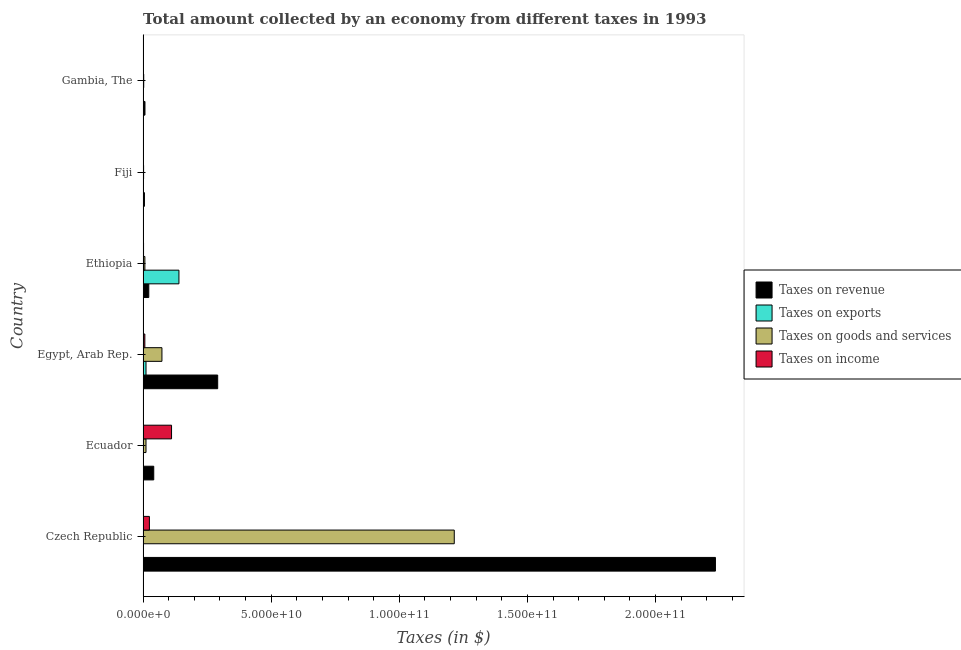How many different coloured bars are there?
Provide a short and direct response. 4. Are the number of bars per tick equal to the number of legend labels?
Make the answer very short. Yes. What is the label of the 2nd group of bars from the top?
Give a very brief answer. Fiji. What is the amount collected as tax on exports in Egypt, Arab Rep.?
Your answer should be compact. 1.15e+09. Across all countries, what is the maximum amount collected as tax on goods?
Ensure brevity in your answer.  1.21e+11. Across all countries, what is the minimum amount collected as tax on goods?
Provide a succinct answer. 2.04e+08. In which country was the amount collected as tax on revenue maximum?
Your response must be concise. Czech Republic. In which country was the amount collected as tax on goods minimum?
Give a very brief answer. Fiji. What is the total amount collected as tax on income in the graph?
Provide a short and direct response. 1.46e+1. What is the difference between the amount collected as tax on goods in Egypt, Arab Rep. and that in Gambia, The?
Your answer should be compact. 7.11e+09. What is the difference between the amount collected as tax on income in Fiji and the amount collected as tax on revenue in Czech Republic?
Make the answer very short. -2.23e+11. What is the average amount collected as tax on exports per country?
Your answer should be very brief. 2.53e+09. What is the difference between the amount collected as tax on income and amount collected as tax on revenue in Egypt, Arab Rep.?
Give a very brief answer. -2.84e+1. What is the ratio of the amount collected as tax on income in Ethiopia to that in Fiji?
Give a very brief answer. 1.67. Is the amount collected as tax on income in Egypt, Arab Rep. less than that in Fiji?
Your response must be concise. No. Is the difference between the amount collected as tax on goods in Czech Republic and Egypt, Arab Rep. greater than the difference between the amount collected as tax on income in Czech Republic and Egypt, Arab Rep.?
Offer a very short reply. Yes. What is the difference between the highest and the second highest amount collected as tax on income?
Give a very brief answer. 8.64e+09. What is the difference between the highest and the lowest amount collected as tax on revenue?
Provide a short and direct response. 2.23e+11. In how many countries, is the amount collected as tax on goods greater than the average amount collected as tax on goods taken over all countries?
Offer a very short reply. 1. Is the sum of the amount collected as tax on income in Czech Republic and Fiji greater than the maximum amount collected as tax on exports across all countries?
Keep it short and to the point. No. What does the 2nd bar from the top in Ecuador represents?
Keep it short and to the point. Taxes on goods and services. What does the 1st bar from the bottom in Ethiopia represents?
Your response must be concise. Taxes on revenue. Is it the case that in every country, the sum of the amount collected as tax on revenue and amount collected as tax on exports is greater than the amount collected as tax on goods?
Provide a succinct answer. Yes. How many countries are there in the graph?
Provide a succinct answer. 6. What is the difference between two consecutive major ticks on the X-axis?
Provide a succinct answer. 5.00e+1. Are the values on the major ticks of X-axis written in scientific E-notation?
Offer a terse response. Yes. Does the graph contain any zero values?
Your answer should be very brief. No. Where does the legend appear in the graph?
Your answer should be compact. Center right. How many legend labels are there?
Your response must be concise. 4. How are the legend labels stacked?
Provide a short and direct response. Vertical. What is the title of the graph?
Provide a short and direct response. Total amount collected by an economy from different taxes in 1993. Does "Primary" appear as one of the legend labels in the graph?
Ensure brevity in your answer.  No. What is the label or title of the X-axis?
Offer a terse response. Taxes (in $). What is the label or title of the Y-axis?
Ensure brevity in your answer.  Country. What is the Taxes (in $) of Taxes on revenue in Czech Republic?
Ensure brevity in your answer.  2.23e+11. What is the Taxes (in $) in Taxes on exports in Czech Republic?
Offer a terse response. 10000. What is the Taxes (in $) of Taxes on goods and services in Czech Republic?
Ensure brevity in your answer.  1.21e+11. What is the Taxes (in $) of Taxes on income in Czech Republic?
Your answer should be very brief. 2.48e+09. What is the Taxes (in $) of Taxes on revenue in Ecuador?
Give a very brief answer. 4.17e+09. What is the Taxes (in $) in Taxes on exports in Ecuador?
Your answer should be compact. 10000. What is the Taxes (in $) of Taxes on goods and services in Ecuador?
Make the answer very short. 1.15e+09. What is the Taxes (in $) of Taxes on income in Ecuador?
Provide a succinct answer. 1.11e+1. What is the Taxes (in $) of Taxes on revenue in Egypt, Arab Rep.?
Keep it short and to the point. 2.91e+1. What is the Taxes (in $) in Taxes on exports in Egypt, Arab Rep.?
Offer a terse response. 1.15e+09. What is the Taxes (in $) of Taxes on goods and services in Egypt, Arab Rep.?
Offer a very short reply. 7.36e+09. What is the Taxes (in $) of Taxes on income in Egypt, Arab Rep.?
Your answer should be compact. 6.94e+08. What is the Taxes (in $) of Taxes on revenue in Ethiopia?
Your answer should be compact. 2.23e+09. What is the Taxes (in $) of Taxes on exports in Ethiopia?
Provide a short and direct response. 1.40e+1. What is the Taxes (in $) of Taxes on goods and services in Ethiopia?
Offer a very short reply. 7.09e+08. What is the Taxes (in $) of Taxes on income in Ethiopia?
Make the answer very short. 1.91e+08. What is the Taxes (in $) in Taxes on revenue in Fiji?
Ensure brevity in your answer.  5.40e+08. What is the Taxes (in $) in Taxes on goods and services in Fiji?
Provide a short and direct response. 2.04e+08. What is the Taxes (in $) in Taxes on income in Fiji?
Provide a short and direct response. 1.15e+08. What is the Taxes (in $) in Taxes on revenue in Gambia, The?
Keep it short and to the point. 7.44e+08. What is the Taxes (in $) in Taxes on exports in Gambia, The?
Offer a terse response. 3.65e+05. What is the Taxes (in $) of Taxes on goods and services in Gambia, The?
Ensure brevity in your answer.  2.57e+08. What is the Taxes (in $) in Taxes on income in Gambia, The?
Offer a very short reply. 1.10e+07. Across all countries, what is the maximum Taxes (in $) of Taxes on revenue?
Provide a succinct answer. 2.23e+11. Across all countries, what is the maximum Taxes (in $) in Taxes on exports?
Keep it short and to the point. 1.40e+1. Across all countries, what is the maximum Taxes (in $) in Taxes on goods and services?
Provide a short and direct response. 1.21e+11. Across all countries, what is the maximum Taxes (in $) of Taxes on income?
Your answer should be very brief. 1.11e+1. Across all countries, what is the minimum Taxes (in $) in Taxes on revenue?
Your answer should be compact. 5.40e+08. Across all countries, what is the minimum Taxes (in $) of Taxes on exports?
Give a very brief answer. 10000. Across all countries, what is the minimum Taxes (in $) in Taxes on goods and services?
Provide a succinct answer. 2.04e+08. Across all countries, what is the minimum Taxes (in $) in Taxes on income?
Your response must be concise. 1.10e+07. What is the total Taxes (in $) of Taxes on revenue in the graph?
Make the answer very short. 2.60e+11. What is the total Taxes (in $) of Taxes on exports in the graph?
Your answer should be compact. 1.52e+1. What is the total Taxes (in $) of Taxes on goods and services in the graph?
Provide a succinct answer. 1.31e+11. What is the total Taxes (in $) of Taxes on income in the graph?
Give a very brief answer. 1.46e+1. What is the difference between the Taxes (in $) in Taxes on revenue in Czech Republic and that in Ecuador?
Ensure brevity in your answer.  2.19e+11. What is the difference between the Taxes (in $) in Taxes on goods and services in Czech Republic and that in Ecuador?
Keep it short and to the point. 1.20e+11. What is the difference between the Taxes (in $) of Taxes on income in Czech Republic and that in Ecuador?
Your response must be concise. -8.64e+09. What is the difference between the Taxes (in $) in Taxes on revenue in Czech Republic and that in Egypt, Arab Rep.?
Ensure brevity in your answer.  1.94e+11. What is the difference between the Taxes (in $) in Taxes on exports in Czech Republic and that in Egypt, Arab Rep.?
Provide a short and direct response. -1.15e+09. What is the difference between the Taxes (in $) in Taxes on goods and services in Czech Republic and that in Egypt, Arab Rep.?
Provide a succinct answer. 1.14e+11. What is the difference between the Taxes (in $) in Taxes on income in Czech Republic and that in Egypt, Arab Rep.?
Your answer should be very brief. 1.78e+09. What is the difference between the Taxes (in $) of Taxes on revenue in Czech Republic and that in Ethiopia?
Provide a succinct answer. 2.21e+11. What is the difference between the Taxes (in $) in Taxes on exports in Czech Republic and that in Ethiopia?
Offer a very short reply. -1.40e+1. What is the difference between the Taxes (in $) of Taxes on goods and services in Czech Republic and that in Ethiopia?
Your answer should be very brief. 1.21e+11. What is the difference between the Taxes (in $) of Taxes on income in Czech Republic and that in Ethiopia?
Keep it short and to the point. 2.29e+09. What is the difference between the Taxes (in $) in Taxes on revenue in Czech Republic and that in Fiji?
Offer a very short reply. 2.23e+11. What is the difference between the Taxes (in $) in Taxes on exports in Czech Republic and that in Fiji?
Make the answer very short. -9.90e+05. What is the difference between the Taxes (in $) in Taxes on goods and services in Czech Republic and that in Fiji?
Your response must be concise. 1.21e+11. What is the difference between the Taxes (in $) in Taxes on income in Czech Republic and that in Fiji?
Your answer should be compact. 2.36e+09. What is the difference between the Taxes (in $) of Taxes on revenue in Czech Republic and that in Gambia, The?
Your response must be concise. 2.23e+11. What is the difference between the Taxes (in $) in Taxes on exports in Czech Republic and that in Gambia, The?
Make the answer very short. -3.55e+05. What is the difference between the Taxes (in $) in Taxes on goods and services in Czech Republic and that in Gambia, The?
Keep it short and to the point. 1.21e+11. What is the difference between the Taxes (in $) of Taxes on income in Czech Republic and that in Gambia, The?
Your answer should be compact. 2.47e+09. What is the difference between the Taxes (in $) in Taxes on revenue in Ecuador and that in Egypt, Arab Rep.?
Provide a succinct answer. -2.50e+1. What is the difference between the Taxes (in $) in Taxes on exports in Ecuador and that in Egypt, Arab Rep.?
Offer a very short reply. -1.15e+09. What is the difference between the Taxes (in $) of Taxes on goods and services in Ecuador and that in Egypt, Arab Rep.?
Offer a terse response. -6.21e+09. What is the difference between the Taxes (in $) in Taxes on income in Ecuador and that in Egypt, Arab Rep.?
Give a very brief answer. 1.04e+1. What is the difference between the Taxes (in $) in Taxes on revenue in Ecuador and that in Ethiopia?
Give a very brief answer. 1.94e+09. What is the difference between the Taxes (in $) of Taxes on exports in Ecuador and that in Ethiopia?
Give a very brief answer. -1.40e+1. What is the difference between the Taxes (in $) in Taxes on goods and services in Ecuador and that in Ethiopia?
Offer a very short reply. 4.40e+08. What is the difference between the Taxes (in $) of Taxes on income in Ecuador and that in Ethiopia?
Give a very brief answer. 1.09e+1. What is the difference between the Taxes (in $) in Taxes on revenue in Ecuador and that in Fiji?
Your answer should be compact. 3.63e+09. What is the difference between the Taxes (in $) of Taxes on exports in Ecuador and that in Fiji?
Give a very brief answer. -9.90e+05. What is the difference between the Taxes (in $) in Taxes on goods and services in Ecuador and that in Fiji?
Keep it short and to the point. 9.45e+08. What is the difference between the Taxes (in $) of Taxes on income in Ecuador and that in Fiji?
Your response must be concise. 1.10e+1. What is the difference between the Taxes (in $) of Taxes on revenue in Ecuador and that in Gambia, The?
Your answer should be compact. 3.43e+09. What is the difference between the Taxes (in $) of Taxes on exports in Ecuador and that in Gambia, The?
Provide a succinct answer. -3.55e+05. What is the difference between the Taxes (in $) in Taxes on goods and services in Ecuador and that in Gambia, The?
Your response must be concise. 8.92e+08. What is the difference between the Taxes (in $) in Taxes on income in Ecuador and that in Gambia, The?
Offer a very short reply. 1.11e+1. What is the difference between the Taxes (in $) of Taxes on revenue in Egypt, Arab Rep. and that in Ethiopia?
Give a very brief answer. 2.69e+1. What is the difference between the Taxes (in $) in Taxes on exports in Egypt, Arab Rep. and that in Ethiopia?
Provide a short and direct response. -1.28e+1. What is the difference between the Taxes (in $) of Taxes on goods and services in Egypt, Arab Rep. and that in Ethiopia?
Offer a terse response. 6.65e+09. What is the difference between the Taxes (in $) of Taxes on income in Egypt, Arab Rep. and that in Ethiopia?
Give a very brief answer. 5.02e+08. What is the difference between the Taxes (in $) of Taxes on revenue in Egypt, Arab Rep. and that in Fiji?
Your answer should be compact. 2.86e+1. What is the difference between the Taxes (in $) of Taxes on exports in Egypt, Arab Rep. and that in Fiji?
Your answer should be very brief. 1.15e+09. What is the difference between the Taxes (in $) in Taxes on goods and services in Egypt, Arab Rep. and that in Fiji?
Provide a succinct answer. 7.16e+09. What is the difference between the Taxes (in $) of Taxes on income in Egypt, Arab Rep. and that in Fiji?
Offer a terse response. 5.79e+08. What is the difference between the Taxes (in $) of Taxes on revenue in Egypt, Arab Rep. and that in Gambia, The?
Your answer should be very brief. 2.84e+1. What is the difference between the Taxes (in $) in Taxes on exports in Egypt, Arab Rep. and that in Gambia, The?
Your answer should be very brief. 1.15e+09. What is the difference between the Taxes (in $) in Taxes on goods and services in Egypt, Arab Rep. and that in Gambia, The?
Provide a succinct answer. 7.11e+09. What is the difference between the Taxes (in $) in Taxes on income in Egypt, Arab Rep. and that in Gambia, The?
Give a very brief answer. 6.83e+08. What is the difference between the Taxes (in $) of Taxes on revenue in Ethiopia and that in Fiji?
Provide a short and direct response. 1.69e+09. What is the difference between the Taxes (in $) in Taxes on exports in Ethiopia and that in Fiji?
Offer a terse response. 1.40e+1. What is the difference between the Taxes (in $) of Taxes on goods and services in Ethiopia and that in Fiji?
Provide a succinct answer. 5.05e+08. What is the difference between the Taxes (in $) in Taxes on income in Ethiopia and that in Fiji?
Your response must be concise. 7.64e+07. What is the difference between the Taxes (in $) in Taxes on revenue in Ethiopia and that in Gambia, The?
Ensure brevity in your answer.  1.49e+09. What is the difference between the Taxes (in $) in Taxes on exports in Ethiopia and that in Gambia, The?
Make the answer very short. 1.40e+1. What is the difference between the Taxes (in $) in Taxes on goods and services in Ethiopia and that in Gambia, The?
Provide a short and direct response. 4.53e+08. What is the difference between the Taxes (in $) in Taxes on income in Ethiopia and that in Gambia, The?
Provide a short and direct response. 1.80e+08. What is the difference between the Taxes (in $) in Taxes on revenue in Fiji and that in Gambia, The?
Make the answer very short. -2.04e+08. What is the difference between the Taxes (in $) in Taxes on exports in Fiji and that in Gambia, The?
Your answer should be compact. 6.35e+05. What is the difference between the Taxes (in $) in Taxes on goods and services in Fiji and that in Gambia, The?
Keep it short and to the point. -5.24e+07. What is the difference between the Taxes (in $) in Taxes on income in Fiji and that in Gambia, The?
Provide a succinct answer. 1.04e+08. What is the difference between the Taxes (in $) in Taxes on revenue in Czech Republic and the Taxes (in $) in Taxes on exports in Ecuador?
Your response must be concise. 2.23e+11. What is the difference between the Taxes (in $) of Taxes on revenue in Czech Republic and the Taxes (in $) of Taxes on goods and services in Ecuador?
Make the answer very short. 2.22e+11. What is the difference between the Taxes (in $) in Taxes on revenue in Czech Republic and the Taxes (in $) in Taxes on income in Ecuador?
Your response must be concise. 2.12e+11. What is the difference between the Taxes (in $) in Taxes on exports in Czech Republic and the Taxes (in $) in Taxes on goods and services in Ecuador?
Your answer should be very brief. -1.15e+09. What is the difference between the Taxes (in $) of Taxes on exports in Czech Republic and the Taxes (in $) of Taxes on income in Ecuador?
Keep it short and to the point. -1.11e+1. What is the difference between the Taxes (in $) in Taxes on goods and services in Czech Republic and the Taxes (in $) in Taxes on income in Ecuador?
Offer a very short reply. 1.10e+11. What is the difference between the Taxes (in $) of Taxes on revenue in Czech Republic and the Taxes (in $) of Taxes on exports in Egypt, Arab Rep.?
Give a very brief answer. 2.22e+11. What is the difference between the Taxes (in $) of Taxes on revenue in Czech Republic and the Taxes (in $) of Taxes on goods and services in Egypt, Arab Rep.?
Give a very brief answer. 2.16e+11. What is the difference between the Taxes (in $) in Taxes on revenue in Czech Republic and the Taxes (in $) in Taxes on income in Egypt, Arab Rep.?
Offer a very short reply. 2.23e+11. What is the difference between the Taxes (in $) in Taxes on exports in Czech Republic and the Taxes (in $) in Taxes on goods and services in Egypt, Arab Rep.?
Your answer should be compact. -7.36e+09. What is the difference between the Taxes (in $) of Taxes on exports in Czech Republic and the Taxes (in $) of Taxes on income in Egypt, Arab Rep.?
Provide a succinct answer. -6.94e+08. What is the difference between the Taxes (in $) of Taxes on goods and services in Czech Republic and the Taxes (in $) of Taxes on income in Egypt, Arab Rep.?
Offer a very short reply. 1.21e+11. What is the difference between the Taxes (in $) of Taxes on revenue in Czech Republic and the Taxes (in $) of Taxes on exports in Ethiopia?
Offer a very short reply. 2.09e+11. What is the difference between the Taxes (in $) of Taxes on revenue in Czech Republic and the Taxes (in $) of Taxes on goods and services in Ethiopia?
Provide a short and direct response. 2.23e+11. What is the difference between the Taxes (in $) in Taxes on revenue in Czech Republic and the Taxes (in $) in Taxes on income in Ethiopia?
Provide a succinct answer. 2.23e+11. What is the difference between the Taxes (in $) of Taxes on exports in Czech Republic and the Taxes (in $) of Taxes on goods and services in Ethiopia?
Offer a very short reply. -7.09e+08. What is the difference between the Taxes (in $) in Taxes on exports in Czech Republic and the Taxes (in $) in Taxes on income in Ethiopia?
Your answer should be compact. -1.91e+08. What is the difference between the Taxes (in $) in Taxes on goods and services in Czech Republic and the Taxes (in $) in Taxes on income in Ethiopia?
Offer a terse response. 1.21e+11. What is the difference between the Taxes (in $) in Taxes on revenue in Czech Republic and the Taxes (in $) in Taxes on exports in Fiji?
Keep it short and to the point. 2.23e+11. What is the difference between the Taxes (in $) in Taxes on revenue in Czech Republic and the Taxes (in $) in Taxes on goods and services in Fiji?
Your answer should be very brief. 2.23e+11. What is the difference between the Taxes (in $) of Taxes on revenue in Czech Republic and the Taxes (in $) of Taxes on income in Fiji?
Provide a short and direct response. 2.23e+11. What is the difference between the Taxes (in $) in Taxes on exports in Czech Republic and the Taxes (in $) in Taxes on goods and services in Fiji?
Your response must be concise. -2.04e+08. What is the difference between the Taxes (in $) in Taxes on exports in Czech Republic and the Taxes (in $) in Taxes on income in Fiji?
Give a very brief answer. -1.15e+08. What is the difference between the Taxes (in $) of Taxes on goods and services in Czech Republic and the Taxes (in $) of Taxes on income in Fiji?
Offer a very short reply. 1.21e+11. What is the difference between the Taxes (in $) of Taxes on revenue in Czech Republic and the Taxes (in $) of Taxes on exports in Gambia, The?
Keep it short and to the point. 2.23e+11. What is the difference between the Taxes (in $) in Taxes on revenue in Czech Republic and the Taxes (in $) in Taxes on goods and services in Gambia, The?
Make the answer very short. 2.23e+11. What is the difference between the Taxes (in $) of Taxes on revenue in Czech Republic and the Taxes (in $) of Taxes on income in Gambia, The?
Offer a terse response. 2.23e+11. What is the difference between the Taxes (in $) in Taxes on exports in Czech Republic and the Taxes (in $) in Taxes on goods and services in Gambia, The?
Provide a succinct answer. -2.57e+08. What is the difference between the Taxes (in $) of Taxes on exports in Czech Republic and the Taxes (in $) of Taxes on income in Gambia, The?
Give a very brief answer. -1.10e+07. What is the difference between the Taxes (in $) of Taxes on goods and services in Czech Republic and the Taxes (in $) of Taxes on income in Gambia, The?
Provide a short and direct response. 1.21e+11. What is the difference between the Taxes (in $) in Taxes on revenue in Ecuador and the Taxes (in $) in Taxes on exports in Egypt, Arab Rep.?
Offer a terse response. 3.02e+09. What is the difference between the Taxes (in $) in Taxes on revenue in Ecuador and the Taxes (in $) in Taxes on goods and services in Egypt, Arab Rep.?
Offer a very short reply. -3.19e+09. What is the difference between the Taxes (in $) in Taxes on revenue in Ecuador and the Taxes (in $) in Taxes on income in Egypt, Arab Rep.?
Give a very brief answer. 3.48e+09. What is the difference between the Taxes (in $) of Taxes on exports in Ecuador and the Taxes (in $) of Taxes on goods and services in Egypt, Arab Rep.?
Give a very brief answer. -7.36e+09. What is the difference between the Taxes (in $) of Taxes on exports in Ecuador and the Taxes (in $) of Taxes on income in Egypt, Arab Rep.?
Ensure brevity in your answer.  -6.94e+08. What is the difference between the Taxes (in $) in Taxes on goods and services in Ecuador and the Taxes (in $) in Taxes on income in Egypt, Arab Rep.?
Your answer should be compact. 4.55e+08. What is the difference between the Taxes (in $) in Taxes on revenue in Ecuador and the Taxes (in $) in Taxes on exports in Ethiopia?
Keep it short and to the point. -9.83e+09. What is the difference between the Taxes (in $) of Taxes on revenue in Ecuador and the Taxes (in $) of Taxes on goods and services in Ethiopia?
Keep it short and to the point. 3.46e+09. What is the difference between the Taxes (in $) in Taxes on revenue in Ecuador and the Taxes (in $) in Taxes on income in Ethiopia?
Provide a succinct answer. 3.98e+09. What is the difference between the Taxes (in $) in Taxes on exports in Ecuador and the Taxes (in $) in Taxes on goods and services in Ethiopia?
Ensure brevity in your answer.  -7.09e+08. What is the difference between the Taxes (in $) of Taxes on exports in Ecuador and the Taxes (in $) of Taxes on income in Ethiopia?
Your answer should be very brief. -1.91e+08. What is the difference between the Taxes (in $) of Taxes on goods and services in Ecuador and the Taxes (in $) of Taxes on income in Ethiopia?
Keep it short and to the point. 9.58e+08. What is the difference between the Taxes (in $) of Taxes on revenue in Ecuador and the Taxes (in $) of Taxes on exports in Fiji?
Give a very brief answer. 4.17e+09. What is the difference between the Taxes (in $) of Taxes on revenue in Ecuador and the Taxes (in $) of Taxes on goods and services in Fiji?
Make the answer very short. 3.97e+09. What is the difference between the Taxes (in $) in Taxes on revenue in Ecuador and the Taxes (in $) in Taxes on income in Fiji?
Give a very brief answer. 4.06e+09. What is the difference between the Taxes (in $) in Taxes on exports in Ecuador and the Taxes (in $) in Taxes on goods and services in Fiji?
Make the answer very short. -2.04e+08. What is the difference between the Taxes (in $) in Taxes on exports in Ecuador and the Taxes (in $) in Taxes on income in Fiji?
Provide a short and direct response. -1.15e+08. What is the difference between the Taxes (in $) in Taxes on goods and services in Ecuador and the Taxes (in $) in Taxes on income in Fiji?
Ensure brevity in your answer.  1.03e+09. What is the difference between the Taxes (in $) of Taxes on revenue in Ecuador and the Taxes (in $) of Taxes on exports in Gambia, The?
Ensure brevity in your answer.  4.17e+09. What is the difference between the Taxes (in $) in Taxes on revenue in Ecuador and the Taxes (in $) in Taxes on goods and services in Gambia, The?
Your answer should be very brief. 3.92e+09. What is the difference between the Taxes (in $) of Taxes on revenue in Ecuador and the Taxes (in $) of Taxes on income in Gambia, The?
Ensure brevity in your answer.  4.16e+09. What is the difference between the Taxes (in $) of Taxes on exports in Ecuador and the Taxes (in $) of Taxes on goods and services in Gambia, The?
Your response must be concise. -2.57e+08. What is the difference between the Taxes (in $) of Taxes on exports in Ecuador and the Taxes (in $) of Taxes on income in Gambia, The?
Ensure brevity in your answer.  -1.10e+07. What is the difference between the Taxes (in $) of Taxes on goods and services in Ecuador and the Taxes (in $) of Taxes on income in Gambia, The?
Your response must be concise. 1.14e+09. What is the difference between the Taxes (in $) in Taxes on revenue in Egypt, Arab Rep. and the Taxes (in $) in Taxes on exports in Ethiopia?
Ensure brevity in your answer.  1.51e+1. What is the difference between the Taxes (in $) of Taxes on revenue in Egypt, Arab Rep. and the Taxes (in $) of Taxes on goods and services in Ethiopia?
Provide a succinct answer. 2.84e+1. What is the difference between the Taxes (in $) in Taxes on revenue in Egypt, Arab Rep. and the Taxes (in $) in Taxes on income in Ethiopia?
Ensure brevity in your answer.  2.89e+1. What is the difference between the Taxes (in $) in Taxes on exports in Egypt, Arab Rep. and the Taxes (in $) in Taxes on goods and services in Ethiopia?
Make the answer very short. 4.41e+08. What is the difference between the Taxes (in $) of Taxes on exports in Egypt, Arab Rep. and the Taxes (in $) of Taxes on income in Ethiopia?
Give a very brief answer. 9.59e+08. What is the difference between the Taxes (in $) of Taxes on goods and services in Egypt, Arab Rep. and the Taxes (in $) of Taxes on income in Ethiopia?
Offer a very short reply. 7.17e+09. What is the difference between the Taxes (in $) in Taxes on revenue in Egypt, Arab Rep. and the Taxes (in $) in Taxes on exports in Fiji?
Ensure brevity in your answer.  2.91e+1. What is the difference between the Taxes (in $) of Taxes on revenue in Egypt, Arab Rep. and the Taxes (in $) of Taxes on goods and services in Fiji?
Your answer should be very brief. 2.89e+1. What is the difference between the Taxes (in $) in Taxes on revenue in Egypt, Arab Rep. and the Taxes (in $) in Taxes on income in Fiji?
Your answer should be very brief. 2.90e+1. What is the difference between the Taxes (in $) of Taxes on exports in Egypt, Arab Rep. and the Taxes (in $) of Taxes on goods and services in Fiji?
Your answer should be very brief. 9.46e+08. What is the difference between the Taxes (in $) in Taxes on exports in Egypt, Arab Rep. and the Taxes (in $) in Taxes on income in Fiji?
Offer a very short reply. 1.04e+09. What is the difference between the Taxes (in $) of Taxes on goods and services in Egypt, Arab Rep. and the Taxes (in $) of Taxes on income in Fiji?
Provide a short and direct response. 7.25e+09. What is the difference between the Taxes (in $) in Taxes on revenue in Egypt, Arab Rep. and the Taxes (in $) in Taxes on exports in Gambia, The?
Give a very brief answer. 2.91e+1. What is the difference between the Taxes (in $) in Taxes on revenue in Egypt, Arab Rep. and the Taxes (in $) in Taxes on goods and services in Gambia, The?
Provide a short and direct response. 2.89e+1. What is the difference between the Taxes (in $) of Taxes on revenue in Egypt, Arab Rep. and the Taxes (in $) of Taxes on income in Gambia, The?
Keep it short and to the point. 2.91e+1. What is the difference between the Taxes (in $) in Taxes on exports in Egypt, Arab Rep. and the Taxes (in $) in Taxes on goods and services in Gambia, The?
Your answer should be very brief. 8.93e+08. What is the difference between the Taxes (in $) of Taxes on exports in Egypt, Arab Rep. and the Taxes (in $) of Taxes on income in Gambia, The?
Offer a terse response. 1.14e+09. What is the difference between the Taxes (in $) in Taxes on goods and services in Egypt, Arab Rep. and the Taxes (in $) in Taxes on income in Gambia, The?
Offer a very short reply. 7.35e+09. What is the difference between the Taxes (in $) in Taxes on revenue in Ethiopia and the Taxes (in $) in Taxes on exports in Fiji?
Your answer should be compact. 2.23e+09. What is the difference between the Taxes (in $) of Taxes on revenue in Ethiopia and the Taxes (in $) of Taxes on goods and services in Fiji?
Ensure brevity in your answer.  2.03e+09. What is the difference between the Taxes (in $) in Taxes on revenue in Ethiopia and the Taxes (in $) in Taxes on income in Fiji?
Your answer should be compact. 2.12e+09. What is the difference between the Taxes (in $) in Taxes on exports in Ethiopia and the Taxes (in $) in Taxes on goods and services in Fiji?
Your answer should be very brief. 1.38e+1. What is the difference between the Taxes (in $) in Taxes on exports in Ethiopia and the Taxes (in $) in Taxes on income in Fiji?
Provide a succinct answer. 1.39e+1. What is the difference between the Taxes (in $) in Taxes on goods and services in Ethiopia and the Taxes (in $) in Taxes on income in Fiji?
Make the answer very short. 5.94e+08. What is the difference between the Taxes (in $) of Taxes on revenue in Ethiopia and the Taxes (in $) of Taxes on exports in Gambia, The?
Offer a terse response. 2.23e+09. What is the difference between the Taxes (in $) of Taxes on revenue in Ethiopia and the Taxes (in $) of Taxes on goods and services in Gambia, The?
Your answer should be very brief. 1.97e+09. What is the difference between the Taxes (in $) of Taxes on revenue in Ethiopia and the Taxes (in $) of Taxes on income in Gambia, The?
Provide a short and direct response. 2.22e+09. What is the difference between the Taxes (in $) in Taxes on exports in Ethiopia and the Taxes (in $) in Taxes on goods and services in Gambia, The?
Provide a short and direct response. 1.37e+1. What is the difference between the Taxes (in $) of Taxes on exports in Ethiopia and the Taxes (in $) of Taxes on income in Gambia, The?
Offer a terse response. 1.40e+1. What is the difference between the Taxes (in $) in Taxes on goods and services in Ethiopia and the Taxes (in $) in Taxes on income in Gambia, The?
Offer a terse response. 6.98e+08. What is the difference between the Taxes (in $) of Taxes on revenue in Fiji and the Taxes (in $) of Taxes on exports in Gambia, The?
Ensure brevity in your answer.  5.40e+08. What is the difference between the Taxes (in $) of Taxes on revenue in Fiji and the Taxes (in $) of Taxes on goods and services in Gambia, The?
Your answer should be very brief. 2.83e+08. What is the difference between the Taxes (in $) of Taxes on revenue in Fiji and the Taxes (in $) of Taxes on income in Gambia, The?
Make the answer very short. 5.29e+08. What is the difference between the Taxes (in $) in Taxes on exports in Fiji and the Taxes (in $) in Taxes on goods and services in Gambia, The?
Provide a short and direct response. -2.56e+08. What is the difference between the Taxes (in $) of Taxes on exports in Fiji and the Taxes (in $) of Taxes on income in Gambia, The?
Your answer should be very brief. -1.00e+07. What is the difference between the Taxes (in $) in Taxes on goods and services in Fiji and the Taxes (in $) in Taxes on income in Gambia, The?
Offer a very short reply. 1.93e+08. What is the average Taxes (in $) of Taxes on revenue per country?
Your response must be concise. 4.34e+1. What is the average Taxes (in $) of Taxes on exports per country?
Your response must be concise. 2.53e+09. What is the average Taxes (in $) in Taxes on goods and services per country?
Offer a terse response. 2.19e+1. What is the average Taxes (in $) in Taxes on income per country?
Offer a very short reply. 2.43e+09. What is the difference between the Taxes (in $) in Taxes on revenue and Taxes (in $) in Taxes on exports in Czech Republic?
Keep it short and to the point. 2.23e+11. What is the difference between the Taxes (in $) in Taxes on revenue and Taxes (in $) in Taxes on goods and services in Czech Republic?
Give a very brief answer. 1.02e+11. What is the difference between the Taxes (in $) in Taxes on revenue and Taxes (in $) in Taxes on income in Czech Republic?
Your answer should be compact. 2.21e+11. What is the difference between the Taxes (in $) of Taxes on exports and Taxes (in $) of Taxes on goods and services in Czech Republic?
Make the answer very short. -1.21e+11. What is the difference between the Taxes (in $) of Taxes on exports and Taxes (in $) of Taxes on income in Czech Republic?
Your answer should be very brief. -2.48e+09. What is the difference between the Taxes (in $) in Taxes on goods and services and Taxes (in $) in Taxes on income in Czech Republic?
Offer a terse response. 1.19e+11. What is the difference between the Taxes (in $) in Taxes on revenue and Taxes (in $) in Taxes on exports in Ecuador?
Make the answer very short. 4.17e+09. What is the difference between the Taxes (in $) of Taxes on revenue and Taxes (in $) of Taxes on goods and services in Ecuador?
Keep it short and to the point. 3.02e+09. What is the difference between the Taxes (in $) in Taxes on revenue and Taxes (in $) in Taxes on income in Ecuador?
Your response must be concise. -6.94e+09. What is the difference between the Taxes (in $) in Taxes on exports and Taxes (in $) in Taxes on goods and services in Ecuador?
Your response must be concise. -1.15e+09. What is the difference between the Taxes (in $) of Taxes on exports and Taxes (in $) of Taxes on income in Ecuador?
Provide a succinct answer. -1.11e+1. What is the difference between the Taxes (in $) of Taxes on goods and services and Taxes (in $) of Taxes on income in Ecuador?
Your answer should be compact. -9.96e+09. What is the difference between the Taxes (in $) of Taxes on revenue and Taxes (in $) of Taxes on exports in Egypt, Arab Rep.?
Ensure brevity in your answer.  2.80e+1. What is the difference between the Taxes (in $) of Taxes on revenue and Taxes (in $) of Taxes on goods and services in Egypt, Arab Rep.?
Offer a terse response. 2.18e+1. What is the difference between the Taxes (in $) of Taxes on revenue and Taxes (in $) of Taxes on income in Egypt, Arab Rep.?
Give a very brief answer. 2.84e+1. What is the difference between the Taxes (in $) in Taxes on exports and Taxes (in $) in Taxes on goods and services in Egypt, Arab Rep.?
Your answer should be compact. -6.21e+09. What is the difference between the Taxes (in $) of Taxes on exports and Taxes (in $) of Taxes on income in Egypt, Arab Rep.?
Provide a succinct answer. 4.56e+08. What is the difference between the Taxes (in $) in Taxes on goods and services and Taxes (in $) in Taxes on income in Egypt, Arab Rep.?
Make the answer very short. 6.67e+09. What is the difference between the Taxes (in $) in Taxes on revenue and Taxes (in $) in Taxes on exports in Ethiopia?
Provide a short and direct response. -1.18e+1. What is the difference between the Taxes (in $) of Taxes on revenue and Taxes (in $) of Taxes on goods and services in Ethiopia?
Your answer should be compact. 1.52e+09. What is the difference between the Taxes (in $) of Taxes on revenue and Taxes (in $) of Taxes on income in Ethiopia?
Provide a succinct answer. 2.04e+09. What is the difference between the Taxes (in $) of Taxes on exports and Taxes (in $) of Taxes on goods and services in Ethiopia?
Provide a short and direct response. 1.33e+1. What is the difference between the Taxes (in $) of Taxes on exports and Taxes (in $) of Taxes on income in Ethiopia?
Provide a succinct answer. 1.38e+1. What is the difference between the Taxes (in $) in Taxes on goods and services and Taxes (in $) in Taxes on income in Ethiopia?
Offer a very short reply. 5.18e+08. What is the difference between the Taxes (in $) in Taxes on revenue and Taxes (in $) in Taxes on exports in Fiji?
Your answer should be compact. 5.39e+08. What is the difference between the Taxes (in $) in Taxes on revenue and Taxes (in $) in Taxes on goods and services in Fiji?
Give a very brief answer. 3.36e+08. What is the difference between the Taxes (in $) in Taxes on revenue and Taxes (in $) in Taxes on income in Fiji?
Ensure brevity in your answer.  4.25e+08. What is the difference between the Taxes (in $) of Taxes on exports and Taxes (in $) of Taxes on goods and services in Fiji?
Provide a short and direct response. -2.03e+08. What is the difference between the Taxes (in $) in Taxes on exports and Taxes (in $) in Taxes on income in Fiji?
Your answer should be compact. -1.14e+08. What is the difference between the Taxes (in $) of Taxes on goods and services and Taxes (in $) of Taxes on income in Fiji?
Make the answer very short. 8.94e+07. What is the difference between the Taxes (in $) in Taxes on revenue and Taxes (in $) in Taxes on exports in Gambia, The?
Make the answer very short. 7.44e+08. What is the difference between the Taxes (in $) of Taxes on revenue and Taxes (in $) of Taxes on goods and services in Gambia, The?
Your answer should be very brief. 4.88e+08. What is the difference between the Taxes (in $) of Taxes on revenue and Taxes (in $) of Taxes on income in Gambia, The?
Make the answer very short. 7.33e+08. What is the difference between the Taxes (in $) of Taxes on exports and Taxes (in $) of Taxes on goods and services in Gambia, The?
Offer a very short reply. -2.56e+08. What is the difference between the Taxes (in $) of Taxes on exports and Taxes (in $) of Taxes on income in Gambia, The?
Keep it short and to the point. -1.07e+07. What is the difference between the Taxes (in $) of Taxes on goods and services and Taxes (in $) of Taxes on income in Gambia, The?
Provide a short and direct response. 2.46e+08. What is the ratio of the Taxes (in $) of Taxes on revenue in Czech Republic to that in Ecuador?
Offer a very short reply. 53.54. What is the ratio of the Taxes (in $) in Taxes on exports in Czech Republic to that in Ecuador?
Keep it short and to the point. 1. What is the ratio of the Taxes (in $) in Taxes on goods and services in Czech Republic to that in Ecuador?
Keep it short and to the point. 105.69. What is the ratio of the Taxes (in $) in Taxes on income in Czech Republic to that in Ecuador?
Give a very brief answer. 0.22. What is the ratio of the Taxes (in $) of Taxes on revenue in Czech Republic to that in Egypt, Arab Rep.?
Your response must be concise. 7.67. What is the ratio of the Taxes (in $) of Taxes on goods and services in Czech Republic to that in Egypt, Arab Rep.?
Ensure brevity in your answer.  16.49. What is the ratio of the Taxes (in $) in Taxes on income in Czech Republic to that in Egypt, Arab Rep.?
Your response must be concise. 3.57. What is the ratio of the Taxes (in $) of Taxes on revenue in Czech Republic to that in Ethiopia?
Your response must be concise. 100.16. What is the ratio of the Taxes (in $) of Taxes on exports in Czech Republic to that in Ethiopia?
Ensure brevity in your answer.  0. What is the ratio of the Taxes (in $) of Taxes on goods and services in Czech Republic to that in Ethiopia?
Ensure brevity in your answer.  171.26. What is the ratio of the Taxes (in $) of Taxes on income in Czech Republic to that in Ethiopia?
Offer a very short reply. 12.97. What is the ratio of the Taxes (in $) in Taxes on revenue in Czech Republic to that in Fiji?
Ensure brevity in your answer.  413.74. What is the ratio of the Taxes (in $) in Taxes on exports in Czech Republic to that in Fiji?
Ensure brevity in your answer.  0.01. What is the ratio of the Taxes (in $) in Taxes on goods and services in Czech Republic to that in Fiji?
Give a very brief answer. 594.93. What is the ratio of the Taxes (in $) of Taxes on income in Czech Republic to that in Fiji?
Your response must be concise. 21.6. What is the ratio of the Taxes (in $) of Taxes on revenue in Czech Republic to that in Gambia, The?
Ensure brevity in your answer.  300.1. What is the ratio of the Taxes (in $) in Taxes on exports in Czech Republic to that in Gambia, The?
Your answer should be very brief. 0.03. What is the ratio of the Taxes (in $) of Taxes on goods and services in Czech Republic to that in Gambia, The?
Give a very brief answer. 473.31. What is the ratio of the Taxes (in $) of Taxes on income in Czech Republic to that in Gambia, The?
Give a very brief answer. 224.66. What is the ratio of the Taxes (in $) of Taxes on revenue in Ecuador to that in Egypt, Arab Rep.?
Your answer should be compact. 0.14. What is the ratio of the Taxes (in $) of Taxes on goods and services in Ecuador to that in Egypt, Arab Rep.?
Offer a very short reply. 0.16. What is the ratio of the Taxes (in $) in Taxes on income in Ecuador to that in Egypt, Arab Rep.?
Your response must be concise. 16.02. What is the ratio of the Taxes (in $) of Taxes on revenue in Ecuador to that in Ethiopia?
Give a very brief answer. 1.87. What is the ratio of the Taxes (in $) of Taxes on exports in Ecuador to that in Ethiopia?
Your response must be concise. 0. What is the ratio of the Taxes (in $) of Taxes on goods and services in Ecuador to that in Ethiopia?
Provide a short and direct response. 1.62. What is the ratio of the Taxes (in $) of Taxes on income in Ecuador to that in Ethiopia?
Ensure brevity in your answer.  58.16. What is the ratio of the Taxes (in $) in Taxes on revenue in Ecuador to that in Fiji?
Provide a succinct answer. 7.73. What is the ratio of the Taxes (in $) in Taxes on exports in Ecuador to that in Fiji?
Ensure brevity in your answer.  0.01. What is the ratio of the Taxes (in $) of Taxes on goods and services in Ecuador to that in Fiji?
Provide a succinct answer. 5.63. What is the ratio of the Taxes (in $) of Taxes on income in Ecuador to that in Fiji?
Give a very brief answer. 96.9. What is the ratio of the Taxes (in $) in Taxes on revenue in Ecuador to that in Gambia, The?
Give a very brief answer. 5.61. What is the ratio of the Taxes (in $) of Taxes on exports in Ecuador to that in Gambia, The?
Your response must be concise. 0.03. What is the ratio of the Taxes (in $) in Taxes on goods and services in Ecuador to that in Gambia, The?
Your answer should be compact. 4.48. What is the ratio of the Taxes (in $) in Taxes on income in Ecuador to that in Gambia, The?
Your answer should be compact. 1007.62. What is the ratio of the Taxes (in $) in Taxes on revenue in Egypt, Arab Rep. to that in Ethiopia?
Ensure brevity in your answer.  13.06. What is the ratio of the Taxes (in $) in Taxes on exports in Egypt, Arab Rep. to that in Ethiopia?
Offer a terse response. 0.08. What is the ratio of the Taxes (in $) of Taxes on goods and services in Egypt, Arab Rep. to that in Ethiopia?
Your answer should be very brief. 10.38. What is the ratio of the Taxes (in $) in Taxes on income in Egypt, Arab Rep. to that in Ethiopia?
Offer a terse response. 3.63. What is the ratio of the Taxes (in $) of Taxes on revenue in Egypt, Arab Rep. to that in Fiji?
Provide a short and direct response. 53.94. What is the ratio of the Taxes (in $) of Taxes on exports in Egypt, Arab Rep. to that in Fiji?
Keep it short and to the point. 1150. What is the ratio of the Taxes (in $) in Taxes on goods and services in Egypt, Arab Rep. to that in Fiji?
Offer a terse response. 36.07. What is the ratio of the Taxes (in $) in Taxes on income in Egypt, Arab Rep. to that in Fiji?
Ensure brevity in your answer.  6.05. What is the ratio of the Taxes (in $) in Taxes on revenue in Egypt, Arab Rep. to that in Gambia, The?
Make the answer very short. 39.13. What is the ratio of the Taxes (in $) of Taxes on exports in Egypt, Arab Rep. to that in Gambia, The?
Offer a terse response. 3150.68. What is the ratio of the Taxes (in $) of Taxes on goods and services in Egypt, Arab Rep. to that in Gambia, The?
Ensure brevity in your answer.  28.7. What is the ratio of the Taxes (in $) in Taxes on income in Egypt, Arab Rep. to that in Gambia, The?
Your answer should be very brief. 62.88. What is the ratio of the Taxes (in $) of Taxes on revenue in Ethiopia to that in Fiji?
Keep it short and to the point. 4.13. What is the ratio of the Taxes (in $) in Taxes on exports in Ethiopia to that in Fiji?
Ensure brevity in your answer.  1.40e+04. What is the ratio of the Taxes (in $) in Taxes on goods and services in Ethiopia to that in Fiji?
Offer a very short reply. 3.47. What is the ratio of the Taxes (in $) in Taxes on income in Ethiopia to that in Fiji?
Your answer should be very brief. 1.67. What is the ratio of the Taxes (in $) of Taxes on revenue in Ethiopia to that in Gambia, The?
Provide a short and direct response. 3. What is the ratio of the Taxes (in $) in Taxes on exports in Ethiopia to that in Gambia, The?
Ensure brevity in your answer.  3.84e+04. What is the ratio of the Taxes (in $) in Taxes on goods and services in Ethiopia to that in Gambia, The?
Provide a short and direct response. 2.76. What is the ratio of the Taxes (in $) of Taxes on income in Ethiopia to that in Gambia, The?
Provide a short and direct response. 17.33. What is the ratio of the Taxes (in $) of Taxes on revenue in Fiji to that in Gambia, The?
Your answer should be compact. 0.73. What is the ratio of the Taxes (in $) in Taxes on exports in Fiji to that in Gambia, The?
Your response must be concise. 2.74. What is the ratio of the Taxes (in $) of Taxes on goods and services in Fiji to that in Gambia, The?
Ensure brevity in your answer.  0.8. What is the ratio of the Taxes (in $) of Taxes on income in Fiji to that in Gambia, The?
Provide a succinct answer. 10.4. What is the difference between the highest and the second highest Taxes (in $) of Taxes on revenue?
Provide a short and direct response. 1.94e+11. What is the difference between the highest and the second highest Taxes (in $) in Taxes on exports?
Keep it short and to the point. 1.28e+1. What is the difference between the highest and the second highest Taxes (in $) of Taxes on goods and services?
Make the answer very short. 1.14e+11. What is the difference between the highest and the second highest Taxes (in $) of Taxes on income?
Make the answer very short. 8.64e+09. What is the difference between the highest and the lowest Taxes (in $) of Taxes on revenue?
Provide a succinct answer. 2.23e+11. What is the difference between the highest and the lowest Taxes (in $) in Taxes on exports?
Ensure brevity in your answer.  1.40e+1. What is the difference between the highest and the lowest Taxes (in $) of Taxes on goods and services?
Keep it short and to the point. 1.21e+11. What is the difference between the highest and the lowest Taxes (in $) of Taxes on income?
Provide a succinct answer. 1.11e+1. 